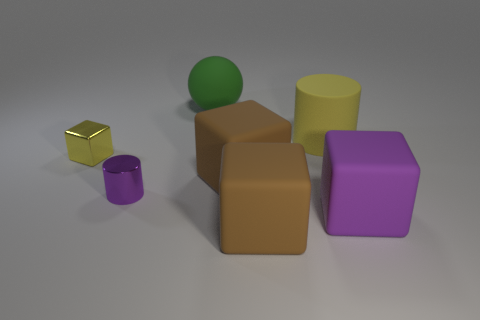Subtract 1 cubes. How many cubes are left? 3 Subtract all red blocks. Subtract all purple spheres. How many blocks are left? 4 Add 3 small yellow balls. How many objects exist? 10 Subtract all spheres. How many objects are left? 6 Subtract 0 red spheres. How many objects are left? 7 Subtract all red rubber blocks. Subtract all brown rubber cubes. How many objects are left? 5 Add 4 purple cylinders. How many purple cylinders are left? 5 Add 7 large red cylinders. How many large red cylinders exist? 7 